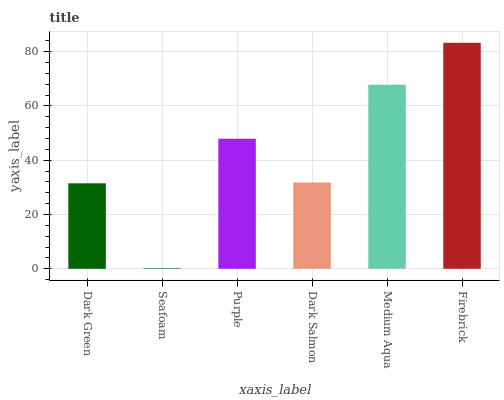Is Seafoam the minimum?
Answer yes or no. Yes. Is Firebrick the maximum?
Answer yes or no. Yes. Is Purple the minimum?
Answer yes or no. No. Is Purple the maximum?
Answer yes or no. No. Is Purple greater than Seafoam?
Answer yes or no. Yes. Is Seafoam less than Purple?
Answer yes or no. Yes. Is Seafoam greater than Purple?
Answer yes or no. No. Is Purple less than Seafoam?
Answer yes or no. No. Is Purple the high median?
Answer yes or no. Yes. Is Dark Salmon the low median?
Answer yes or no. Yes. Is Seafoam the high median?
Answer yes or no. No. Is Firebrick the low median?
Answer yes or no. No. 